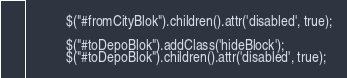<code> <loc_0><loc_0><loc_500><loc_500><_PHP_>			$("#fromCityBlok").children().attr('disabled', true);

			$("#toDepoBlok").addClass('hideBlock');
			$("#toDepoBlok").children().attr('disabled', true);</code> 